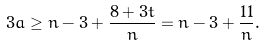Convert formula to latex. <formula><loc_0><loc_0><loc_500><loc_500>3 a \geq n - 3 + \frac { 8 + 3 t } n = n - 3 + \frac { 1 1 } n .</formula> 